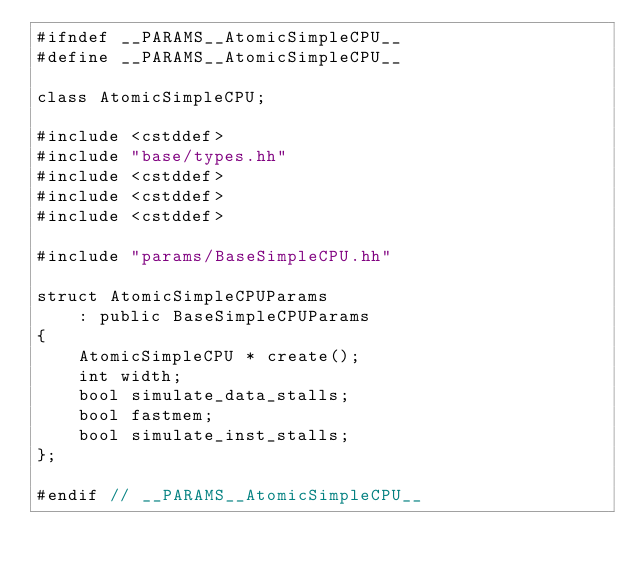Convert code to text. <code><loc_0><loc_0><loc_500><loc_500><_C++_>#ifndef __PARAMS__AtomicSimpleCPU__
#define __PARAMS__AtomicSimpleCPU__

class AtomicSimpleCPU;

#include <cstddef>
#include "base/types.hh"
#include <cstddef>
#include <cstddef>
#include <cstddef>

#include "params/BaseSimpleCPU.hh"

struct AtomicSimpleCPUParams
    : public BaseSimpleCPUParams
{
    AtomicSimpleCPU * create();
    int width;
    bool simulate_data_stalls;
    bool fastmem;
    bool simulate_inst_stalls;
};

#endif // __PARAMS__AtomicSimpleCPU__
</code> 